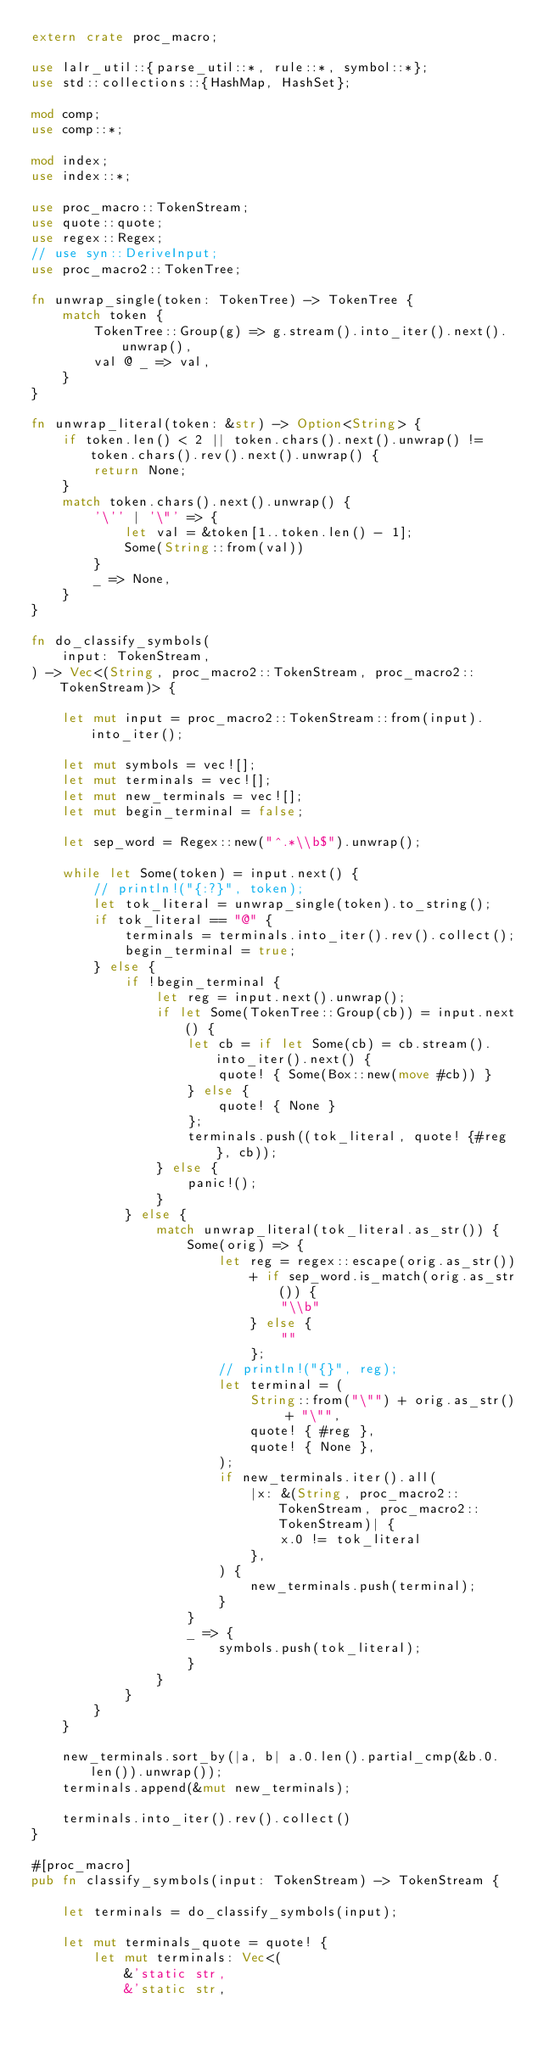Convert code to text. <code><loc_0><loc_0><loc_500><loc_500><_Rust_>extern crate proc_macro;

use lalr_util::{parse_util::*, rule::*, symbol::*};
use std::collections::{HashMap, HashSet};

mod comp;
use comp::*;

mod index;
use index::*;

use proc_macro::TokenStream;
use quote::quote;
use regex::Regex;
// use syn::DeriveInput;
use proc_macro2::TokenTree;

fn unwrap_single(token: TokenTree) -> TokenTree {
    match token {
        TokenTree::Group(g) => g.stream().into_iter().next().unwrap(),
        val @ _ => val,
    }
}

fn unwrap_literal(token: &str) -> Option<String> {
    if token.len() < 2 || token.chars().next().unwrap() != token.chars().rev().next().unwrap() {
        return None;
    }
    match token.chars().next().unwrap() {
        '\'' | '\"' => {
            let val = &token[1..token.len() - 1];
            Some(String::from(val))
        }
        _ => None,
    }
}

fn do_classify_symbols(
    input: TokenStream,
) -> Vec<(String, proc_macro2::TokenStream, proc_macro2::TokenStream)> {

    let mut input = proc_macro2::TokenStream::from(input).into_iter();

    let mut symbols = vec![];
    let mut terminals = vec![];
    let mut new_terminals = vec![];
    let mut begin_terminal = false;

    let sep_word = Regex::new("^.*\\b$").unwrap();

    while let Some(token) = input.next() {
        // println!("{:?}", token);
        let tok_literal = unwrap_single(token).to_string();
        if tok_literal == "@" {
            terminals = terminals.into_iter().rev().collect();
            begin_terminal = true;
        } else {
            if !begin_terminal {
                let reg = input.next().unwrap();
                if let Some(TokenTree::Group(cb)) = input.next() {
                    let cb = if let Some(cb) = cb.stream().into_iter().next() {
                        quote! { Some(Box::new(move #cb)) }
                    } else {
                        quote! { None }
                    };
                    terminals.push((tok_literal, quote! {#reg}, cb));
                } else {
                    panic!();
                }
            } else {
                match unwrap_literal(tok_literal.as_str()) {
                    Some(orig) => {
                        let reg = regex::escape(orig.as_str())
                            + if sep_word.is_match(orig.as_str()) {
                                "\\b"
                            } else {
                                ""
                            };
                        // println!("{}", reg);
                        let terminal = (
                            String::from("\"") + orig.as_str() + "\"",
                            quote! { #reg },
                            quote! { None },
                        );
                        if new_terminals.iter().all(
                            |x: &(String, proc_macro2::TokenStream, proc_macro2::TokenStream)| {
                                x.0 != tok_literal
                            },
                        ) {
                            new_terminals.push(terminal);
                        }
                    }
                    _ => {
                        symbols.push(tok_literal);
                    }
                }
            }
        }
    }

    new_terminals.sort_by(|a, b| a.0.len().partial_cmp(&b.0.len()).unwrap());
    terminals.append(&mut new_terminals);

    terminals.into_iter().rev().collect()
}

#[proc_macro]
pub fn classify_symbols(input: TokenStream) -> TokenStream {

    let terminals = do_classify_symbols(input);

    let mut terminals_quote = quote! {
        let mut terminals: Vec<(
            &'static str,
            &'static str,</code> 